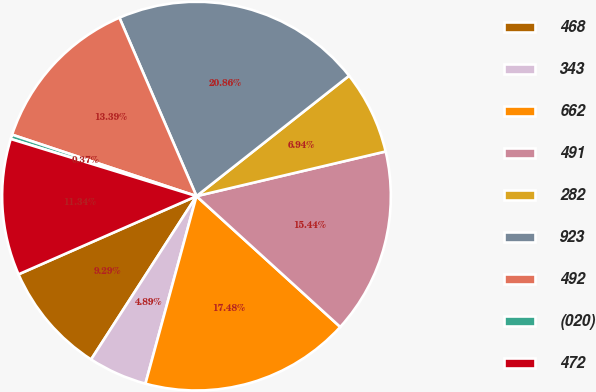Convert chart. <chart><loc_0><loc_0><loc_500><loc_500><pie_chart><fcel>468<fcel>343<fcel>662<fcel>491<fcel>282<fcel>923<fcel>492<fcel>(020)<fcel>472<nl><fcel>9.29%<fcel>4.89%<fcel>17.48%<fcel>15.44%<fcel>6.94%<fcel>20.86%<fcel>13.39%<fcel>0.37%<fcel>11.34%<nl></chart> 